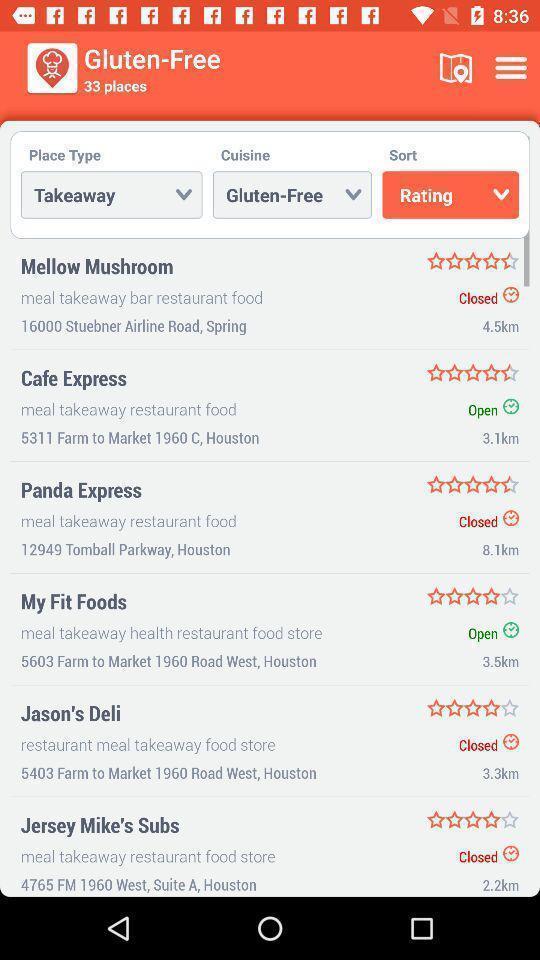Tell me about the visual elements in this screen capture. Screen displaying a list of takeaway restaurants sorted by ratings. 